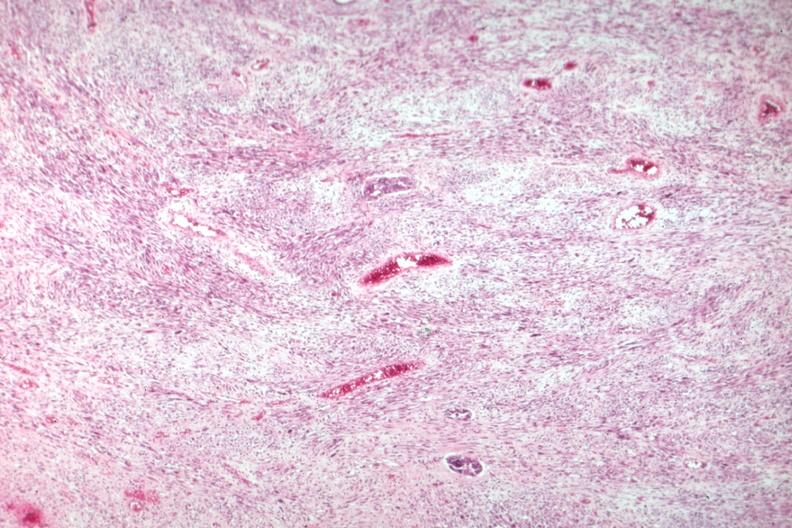what does this image show?
Answer the question using a single word or phrase. Nice view of tumor primarily stromal element 